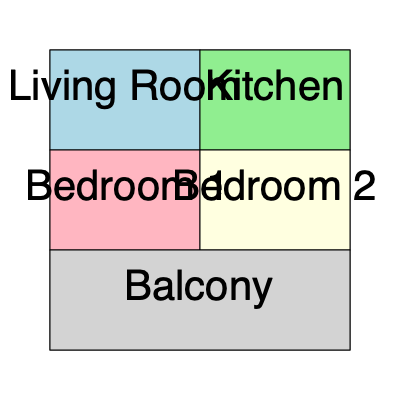In the popular K-drama "My Seoul Sanctuary," the main character's apartment layout is shown above. If you were to rotate the apartment 90 degrees clockwise, which room would be directly above the Living Room? To solve this problem, we need to visualize the rotation of the apartment layout:

1. The current layout has the Living Room in the top-left corner.
2. A 90-degree clockwise rotation means the top row will become the right column.
3. The rotation steps are:
   a. The Living Room moves from top-left to top-right.
   b. The Kitchen moves from top-right to bottom-right.
   c. Bedroom 2 moves from middle-right to bottom-left.
   d. Bedroom 1 moves from middle-left to top-left.
   e. The Balcony moves from bottom to left side.
4. After rotation, the rooms from top to bottom would be:
   Bedroom 1, Living Room, Kitchen
5. Therefore, Bedroom 1 would be directly above the Living Room after the rotation.
Answer: Bedroom 1 